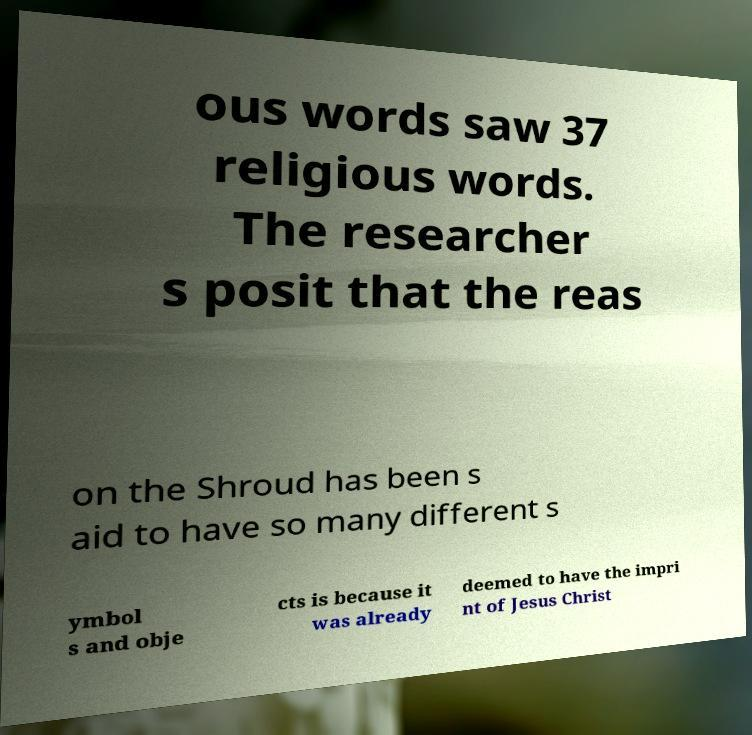Could you assist in decoding the text presented in this image and type it out clearly? ous words saw 37 religious words. The researcher s posit that the reas on the Shroud has been s aid to have so many different s ymbol s and obje cts is because it was already deemed to have the impri nt of Jesus Christ 